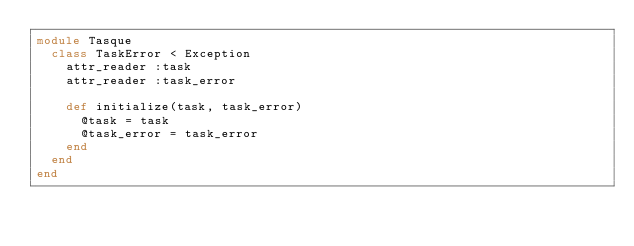Convert code to text. <code><loc_0><loc_0><loc_500><loc_500><_Ruby_>module Tasque
  class TaskError < Exception
    attr_reader :task
    attr_reader :task_error
  
    def initialize(task, task_error)
      @task = task
      @task_error = task_error
    end
  end
end
</code> 